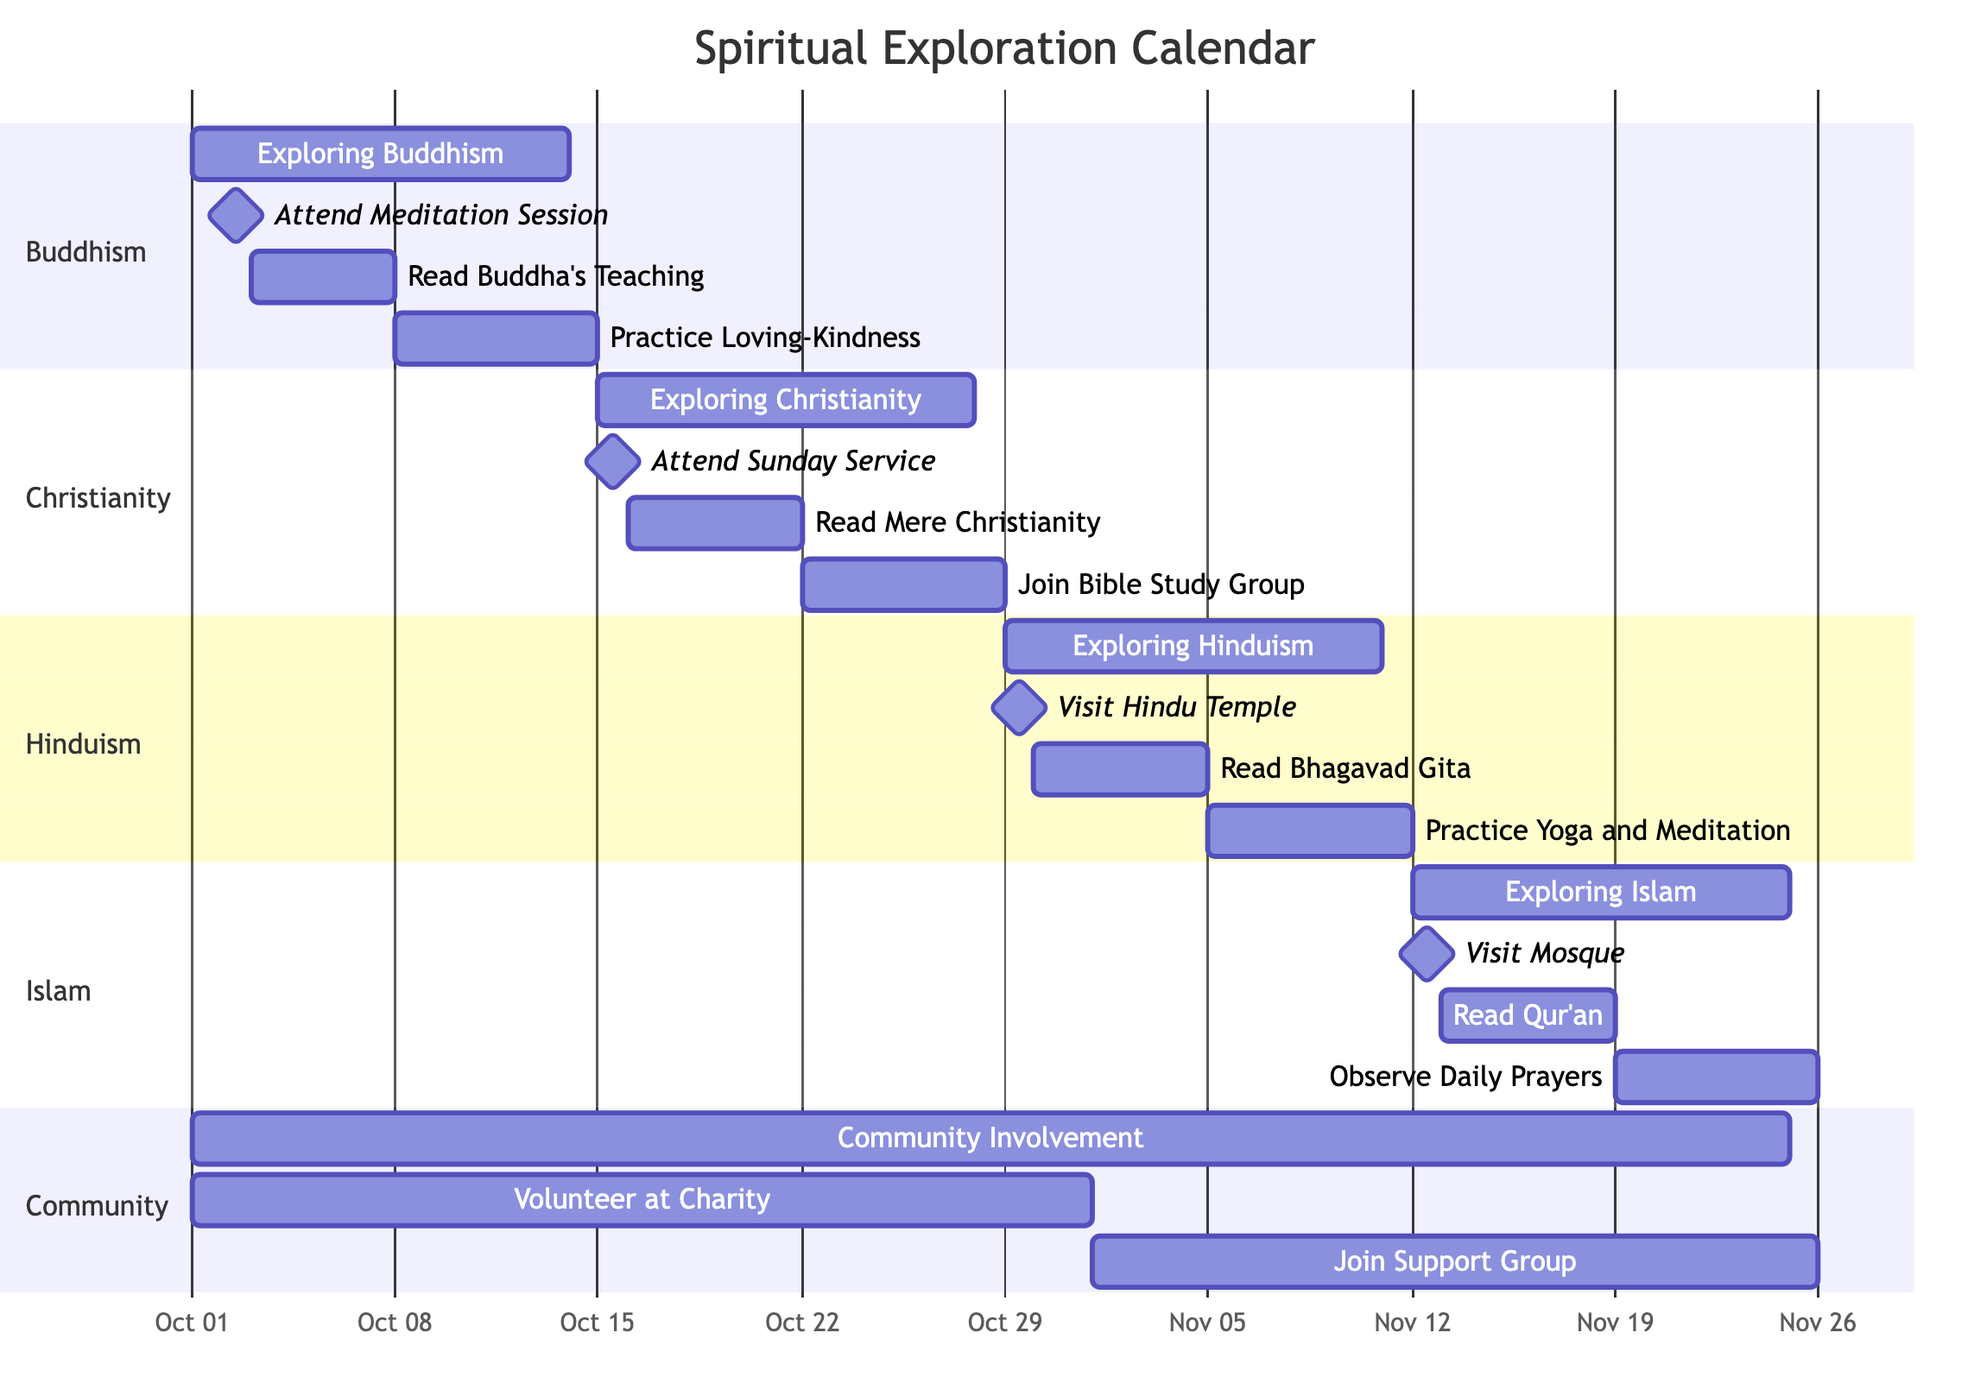What are the total number of main tasks in the diagram? The main tasks listed in the diagram are: Exploring Buddhism, Exploring Christianity, Exploring Hinduism, Exploring Islam, and Community Involvement. Counting these gives a total of five main tasks.
Answer: 5 What is the start date for "Join a Bible Study Group"? The start date for "Join a Bible Study Group" is shown in the subtasks under "Exploring Christianity" as October 22, 2023.
Answer: October 22, 2023 Which task overlaps with "Join a Support Group"? To find the overlapping task, I check the dates for "Join a Support Group," which runs from November 1 to November 25, and see that it overlaps with the entire duration of "Exploring Islam," which is from November 12 to November 25.
Answer: Exploring Islam How long does the "Read 'The Heart of the Buddha's Teaching' by Thich Nhat Hanh" task last? The task "Read 'The Heart of the Buddha's Teaching' by Thich Nhat Hanh" starts on October 3 and ends on October 7, which is a duration of 5 days.
Answer: 5 days What is the end date for the "Practice Yoga and Meditation"? The end date listed for "Practice Yoga and Meditation" is November 11, 2023, as mentioned in the subtasks under "Exploring Hinduism."
Answer: November 11, 2023 How many days are between the start date of "Exploring Buddhism" and the end date of "Community Involvement"? The start date of "Exploring Buddhism" is October 1 and the end date of "Community Involvement" is November 25. Counting these dates gives a total of 55 days from the start to the end of the tasks.
Answer: 55 days Which faith practice has a milestone task on November 12? The milestone task on November 12 is associated with "Visit Mosque," which is part of the "Exploring Islam" section.
Answer: Visit Mosque What is the relationship between "Practice Loving-Kindness Meditation" and "Exploring Buddhism"? "Practice Loving-Kindness Meditation" is a subtask within the main task "Exploring Buddhism," indicating that it is part of the exploration process of Buddhism.
Answer: Subtask of Exploring Buddhism 